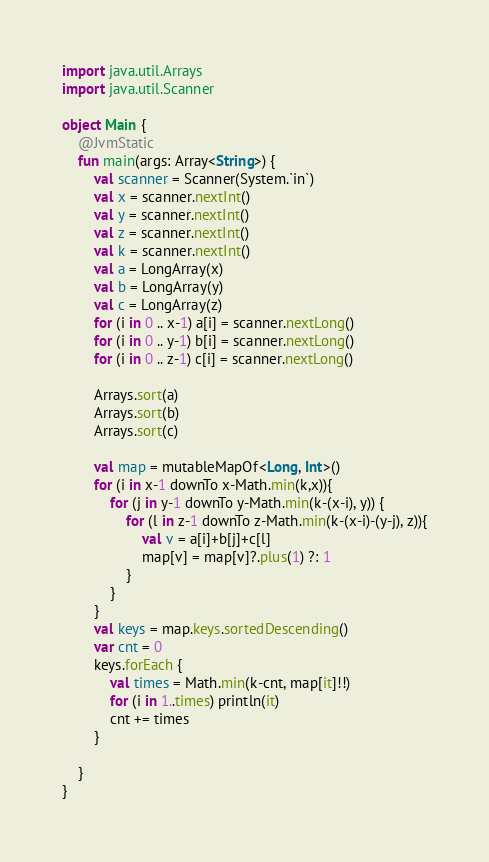<code> <loc_0><loc_0><loc_500><loc_500><_Kotlin_>import java.util.Arrays
import java.util.Scanner

object Main {
	@JvmStatic
	fun main(args: Array<String>) {
		val scanner = Scanner(System.`in`)
		val x = scanner.nextInt()
		val y = scanner.nextInt()
		val z = scanner.nextInt()
		val k = scanner.nextInt()
		val a = LongArray(x)
		val b = LongArray(y)
		val c = LongArray(z)
		for (i in 0 .. x-1) a[i] = scanner.nextLong()
		for (i in 0 .. y-1) b[i] = scanner.nextLong()
		for (i in 0 .. z-1) c[i] = scanner.nextLong()

		Arrays.sort(a)
		Arrays.sort(b)
		Arrays.sort(c)

		val map = mutableMapOf<Long, Int>()
		for (i in x-1 downTo x-Math.min(k,x)){
			for (j in y-1 downTo y-Math.min(k-(x-i), y)) {
				for (l in z-1 downTo z-Math.min(k-(x-i)-(y-j), z)){
					val v = a[i]+b[j]+c[l]
					map[v] = map[v]?.plus(1) ?: 1
				}
			}
		}
		val keys = map.keys.sortedDescending()
		var cnt = 0
		keys.forEach {
			val times = Math.min(k-cnt, map[it]!!)
			for (i in 1..times) println(it)
			cnt += times
		}

	}
}</code> 